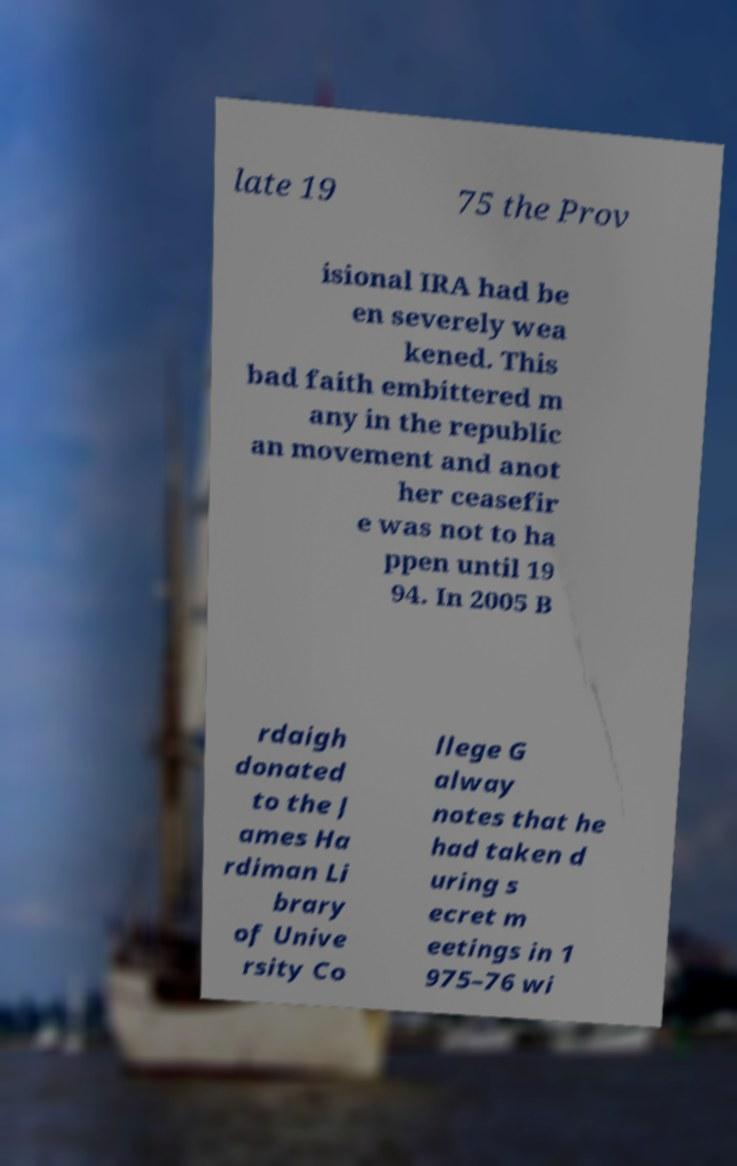Can you read and provide the text displayed in the image?This photo seems to have some interesting text. Can you extract and type it out for me? late 19 75 the Prov isional IRA had be en severely wea kened. This bad faith embittered m any in the republic an movement and anot her ceasefir e was not to ha ppen until 19 94. In 2005 B rdaigh donated to the J ames Ha rdiman Li brary of Unive rsity Co llege G alway notes that he had taken d uring s ecret m eetings in 1 975–76 wi 